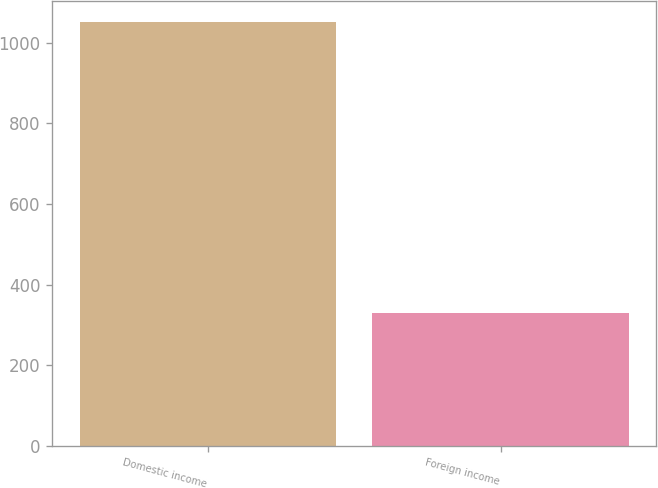<chart> <loc_0><loc_0><loc_500><loc_500><bar_chart><fcel>Domestic income<fcel>Foreign income<nl><fcel>1052<fcel>330<nl></chart> 